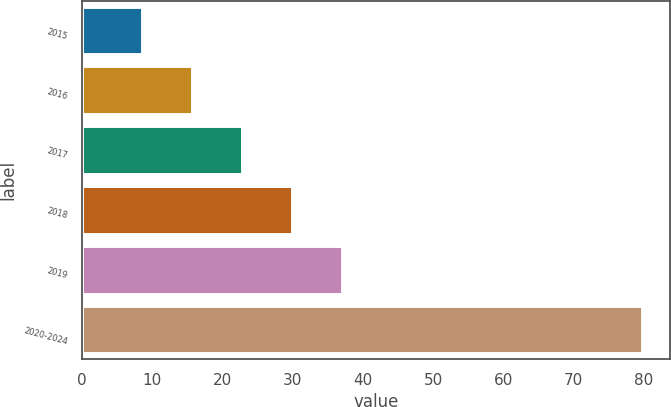Convert chart to OTSL. <chart><loc_0><loc_0><loc_500><loc_500><bar_chart><fcel>2015<fcel>2016<fcel>2017<fcel>2018<fcel>2019<fcel>2020-2024<nl><fcel>8.5<fcel>15.62<fcel>22.74<fcel>29.86<fcel>36.98<fcel>79.7<nl></chart> 